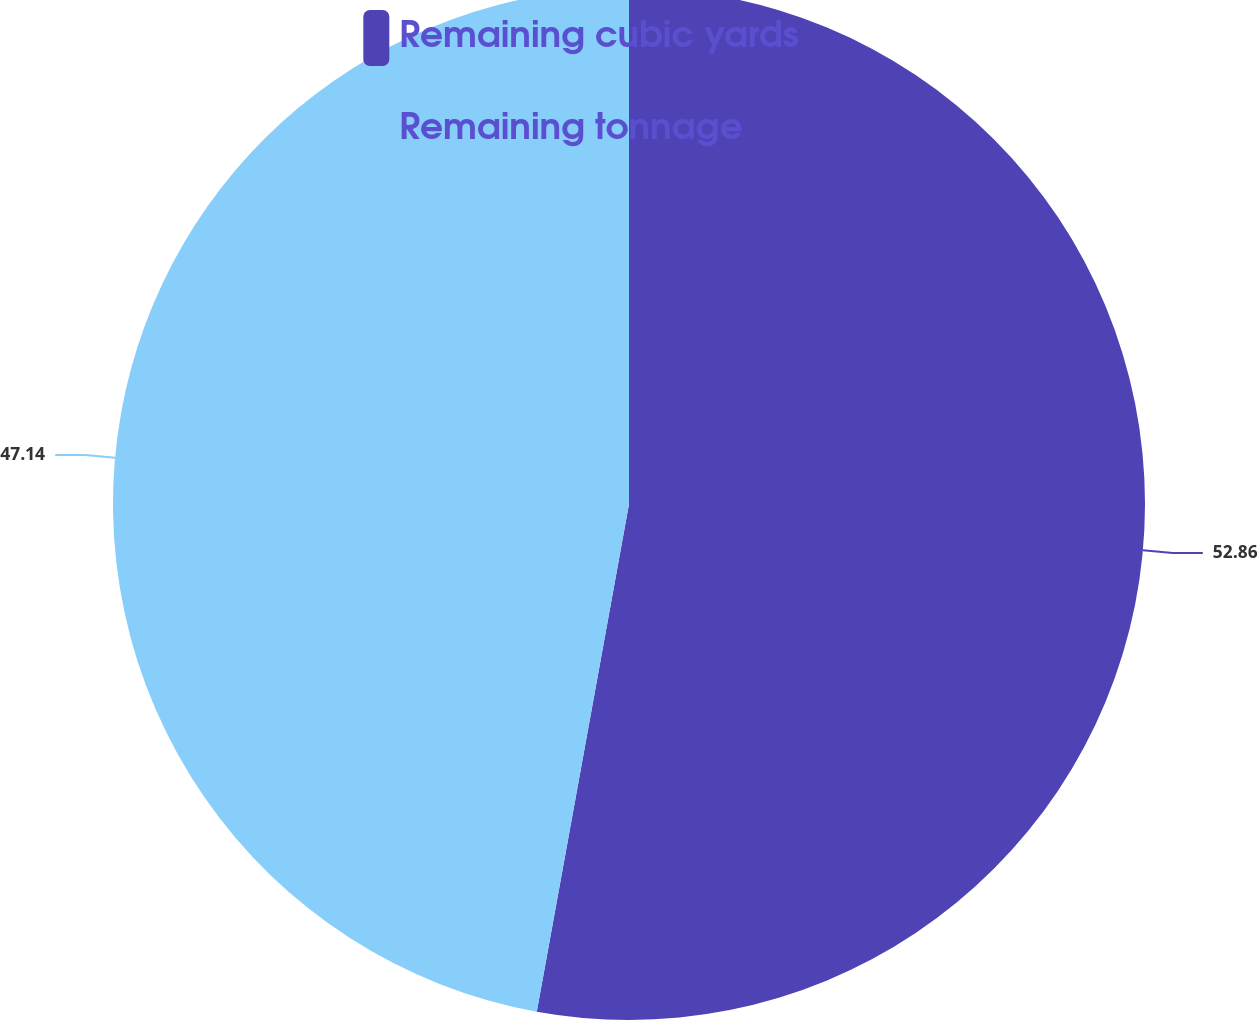Convert chart. <chart><loc_0><loc_0><loc_500><loc_500><pie_chart><fcel>Remaining cubic yards<fcel>Remaining tonnage<nl><fcel>52.86%<fcel>47.14%<nl></chart> 